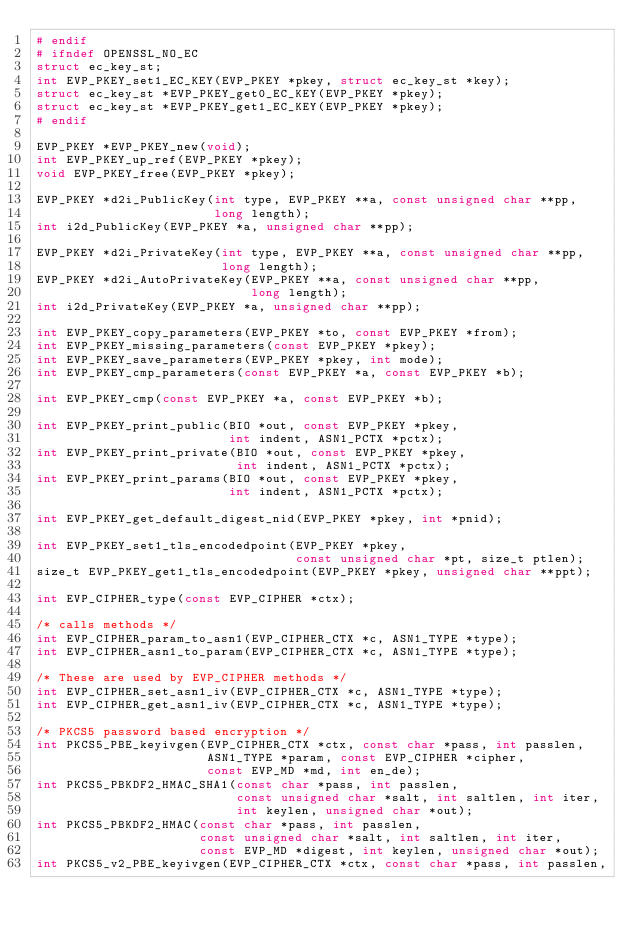<code> <loc_0><loc_0><loc_500><loc_500><_C_># endif
# ifndef OPENSSL_NO_EC
struct ec_key_st;
int EVP_PKEY_set1_EC_KEY(EVP_PKEY *pkey, struct ec_key_st *key);
struct ec_key_st *EVP_PKEY_get0_EC_KEY(EVP_PKEY *pkey);
struct ec_key_st *EVP_PKEY_get1_EC_KEY(EVP_PKEY *pkey);
# endif

EVP_PKEY *EVP_PKEY_new(void);
int EVP_PKEY_up_ref(EVP_PKEY *pkey);
void EVP_PKEY_free(EVP_PKEY *pkey);

EVP_PKEY *d2i_PublicKey(int type, EVP_PKEY **a, const unsigned char **pp,
                        long length);
int i2d_PublicKey(EVP_PKEY *a, unsigned char **pp);

EVP_PKEY *d2i_PrivateKey(int type, EVP_PKEY **a, const unsigned char **pp,
                         long length);
EVP_PKEY *d2i_AutoPrivateKey(EVP_PKEY **a, const unsigned char **pp,
                             long length);
int i2d_PrivateKey(EVP_PKEY *a, unsigned char **pp);

int EVP_PKEY_copy_parameters(EVP_PKEY *to, const EVP_PKEY *from);
int EVP_PKEY_missing_parameters(const EVP_PKEY *pkey);
int EVP_PKEY_save_parameters(EVP_PKEY *pkey, int mode);
int EVP_PKEY_cmp_parameters(const EVP_PKEY *a, const EVP_PKEY *b);

int EVP_PKEY_cmp(const EVP_PKEY *a, const EVP_PKEY *b);

int EVP_PKEY_print_public(BIO *out, const EVP_PKEY *pkey,
                          int indent, ASN1_PCTX *pctx);
int EVP_PKEY_print_private(BIO *out, const EVP_PKEY *pkey,
                           int indent, ASN1_PCTX *pctx);
int EVP_PKEY_print_params(BIO *out, const EVP_PKEY *pkey,
                          int indent, ASN1_PCTX *pctx);

int EVP_PKEY_get_default_digest_nid(EVP_PKEY *pkey, int *pnid);

int EVP_PKEY_set1_tls_encodedpoint(EVP_PKEY *pkey,
                                   const unsigned char *pt, size_t ptlen);
size_t EVP_PKEY_get1_tls_encodedpoint(EVP_PKEY *pkey, unsigned char **ppt);

int EVP_CIPHER_type(const EVP_CIPHER *ctx);

/* calls methods */
int EVP_CIPHER_param_to_asn1(EVP_CIPHER_CTX *c, ASN1_TYPE *type);
int EVP_CIPHER_asn1_to_param(EVP_CIPHER_CTX *c, ASN1_TYPE *type);

/* These are used by EVP_CIPHER methods */
int EVP_CIPHER_set_asn1_iv(EVP_CIPHER_CTX *c, ASN1_TYPE *type);
int EVP_CIPHER_get_asn1_iv(EVP_CIPHER_CTX *c, ASN1_TYPE *type);

/* PKCS5 password based encryption */
int PKCS5_PBE_keyivgen(EVP_CIPHER_CTX *ctx, const char *pass, int passlen,
                       ASN1_TYPE *param, const EVP_CIPHER *cipher,
                       const EVP_MD *md, int en_de);
int PKCS5_PBKDF2_HMAC_SHA1(const char *pass, int passlen,
                           const unsigned char *salt, int saltlen, int iter,
                           int keylen, unsigned char *out);
int PKCS5_PBKDF2_HMAC(const char *pass, int passlen,
                      const unsigned char *salt, int saltlen, int iter,
                      const EVP_MD *digest, int keylen, unsigned char *out);
int PKCS5_v2_PBE_keyivgen(EVP_CIPHER_CTX *ctx, const char *pass, int passlen,</code> 